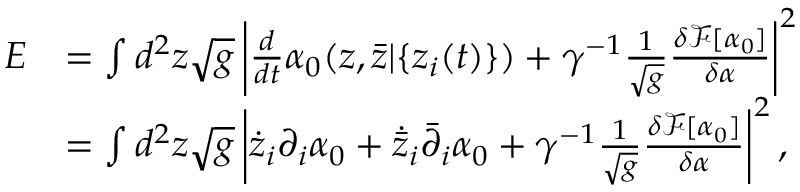<formula> <loc_0><loc_0><loc_500><loc_500>\begin{array} { r l } { E } & { = \int d ^ { 2 } z \sqrt { g } \left | \frac { d } { d t } \alpha _ { 0 } ( z , { \bar { z } } | \{ z _ { i } ( t ) \} ) + \gamma ^ { - 1 } \frac { 1 } { \sqrt { g } } \frac { \delta \mathcal { F } [ \alpha _ { 0 } ] } { \delta \alpha } \right | ^ { 2 } } \\ & { = \int d ^ { 2 } z \sqrt { g } \left | \dot { z } _ { i } \partial _ { i } \alpha _ { 0 } + \dot { \bar { z } } _ { i } \bar { \partial } _ { i } \alpha _ { 0 } + \gamma ^ { - 1 } \frac { 1 } { \sqrt { g } } \frac { \delta \mathcal { F } [ \alpha _ { 0 } ] } { \delta \alpha } \right | ^ { 2 } , } \end{array}</formula> 